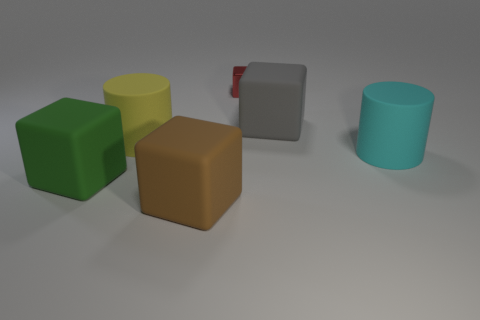The green thing that is the same material as the large gray cube is what shape?
Keep it short and to the point. Cube. Is there any other thing that is the same shape as the tiny red shiny thing?
Your answer should be very brief. Yes. What is the shape of the green matte thing?
Provide a succinct answer. Cube. There is a thing that is left of the yellow thing; is its shape the same as the gray object?
Make the answer very short. Yes. Are there more yellow rubber cylinders to the right of the tiny object than metallic objects left of the large green cube?
Offer a terse response. No. How many other objects are the same size as the red object?
Provide a succinct answer. 0. Is the shape of the large yellow object the same as the rubber thing that is behind the yellow matte object?
Ensure brevity in your answer.  No. How many rubber things are red objects or cyan balls?
Offer a terse response. 0. Are there any other cubes of the same color as the tiny block?
Offer a terse response. No. Are there any large blue shiny objects?
Keep it short and to the point. No. 